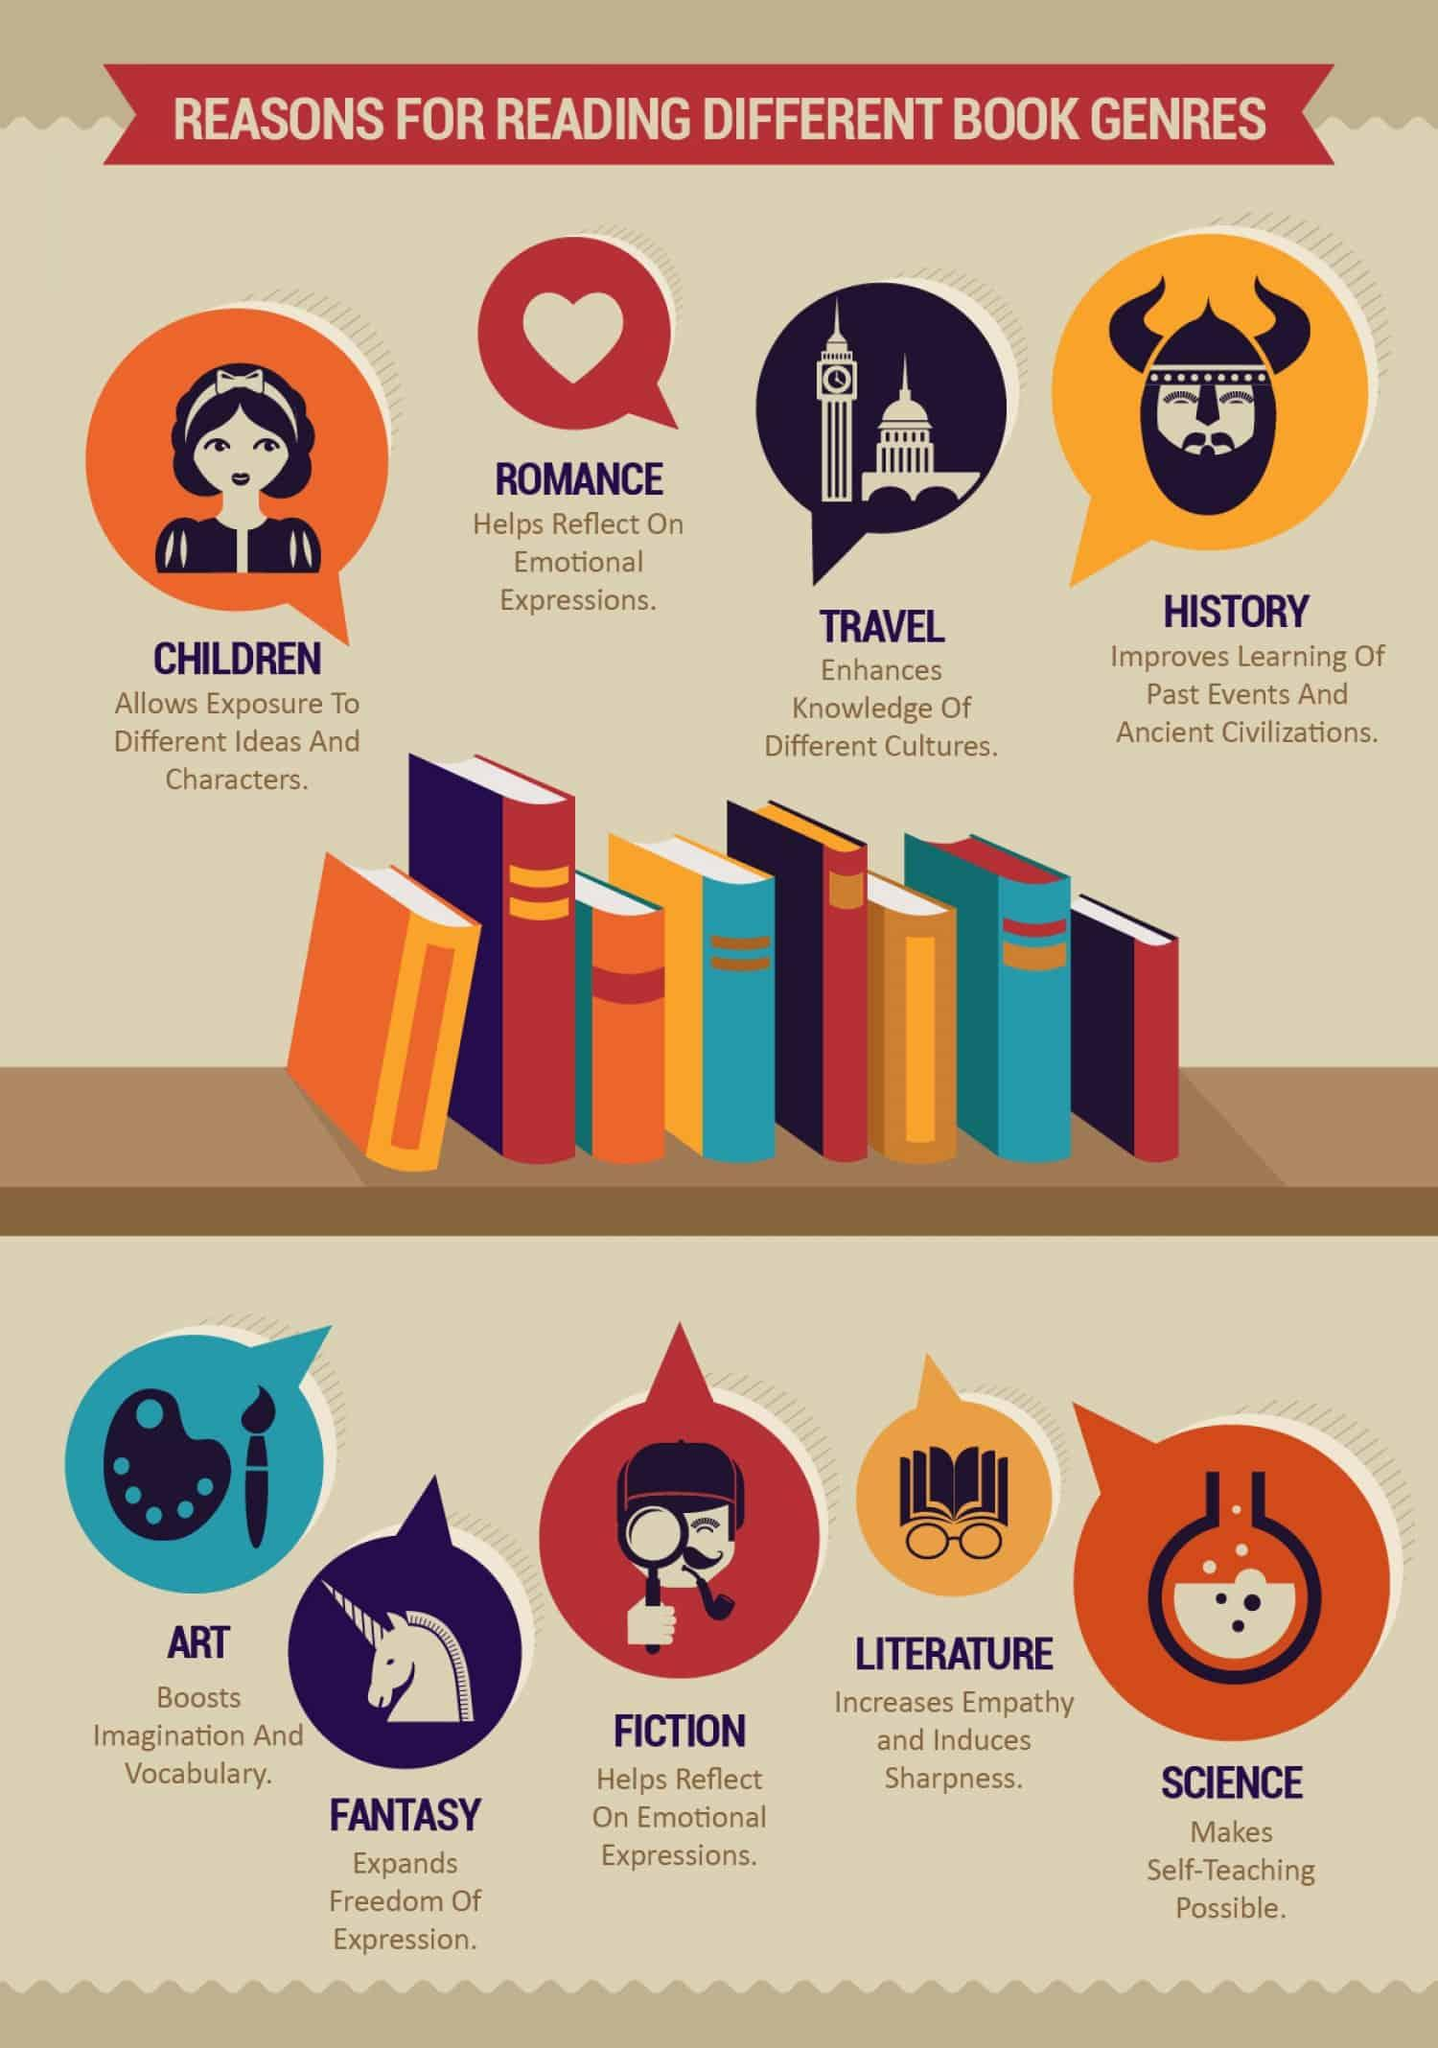List a handful of essential elements in this visual. The second to last genre listed in this infographic is literature. Literature has been shown to increase empathy in individuals. The genre that appears to enhance imagination is art. According to the given infographic, there are a total of 9 different genres. The genre represented by the heart symbol is romance. 